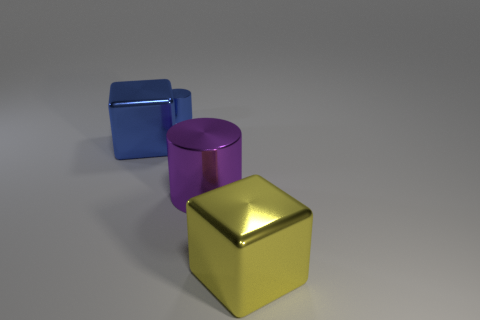Add 4 purple metal cylinders. How many objects exist? 8 Add 4 green rubber cylinders. How many green rubber cylinders exist? 4 Subtract 0 brown balls. How many objects are left? 4 Subtract all large yellow metallic things. Subtract all blocks. How many objects are left? 1 Add 4 large blue objects. How many large blue objects are left? 5 